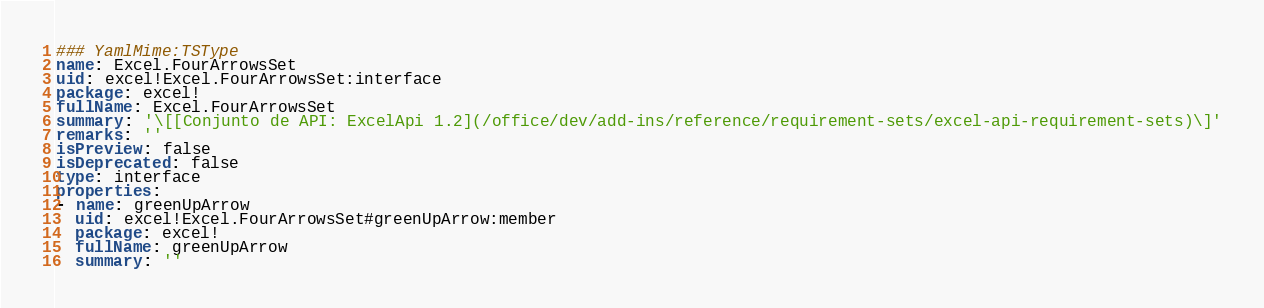<code> <loc_0><loc_0><loc_500><loc_500><_YAML_>### YamlMime:TSType
name: Excel.FourArrowsSet
uid: excel!Excel.FourArrowsSet:interface
package: excel!
fullName: Excel.FourArrowsSet
summary: '\[[Conjunto de API: ExcelApi 1.2](/office/dev/add-ins/reference/requirement-sets/excel-api-requirement-sets)\]'
remarks: ''
isPreview: false
isDeprecated: false
type: interface
properties:
- name: greenUpArrow
  uid: excel!Excel.FourArrowsSet#greenUpArrow:member
  package: excel!
  fullName: greenUpArrow
  summary: ''</code> 